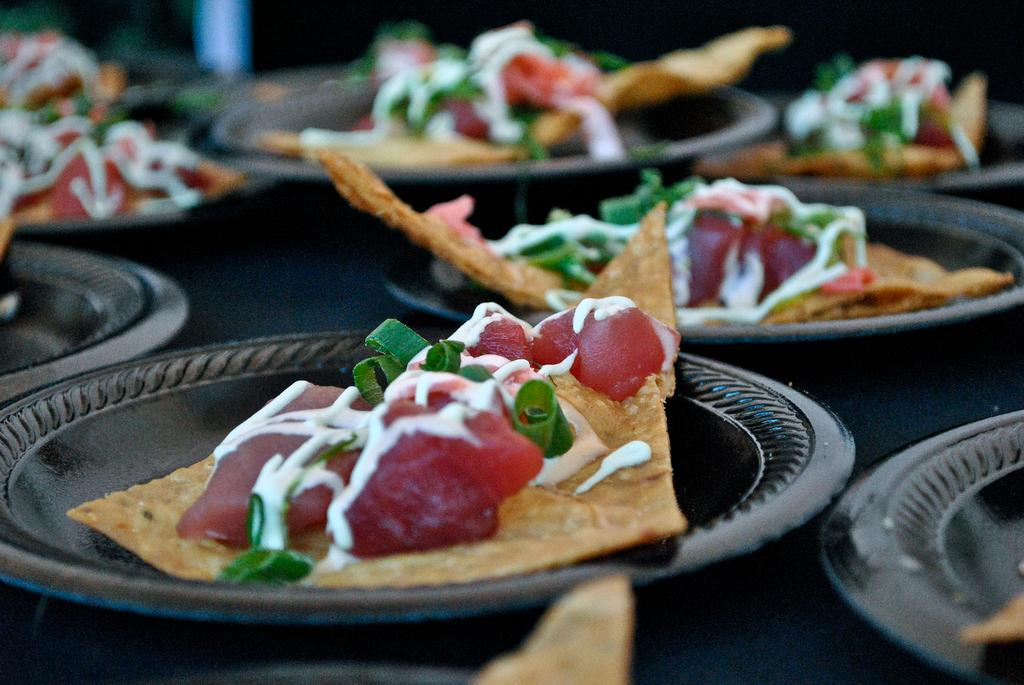What is on the plates in the image? There is food in the plates in the image. What type of food can be seen on the plates? The food appears to be nachos. What is the distribution of the sound waves in the image? There is no mention of sound waves or hearing in the image, so it is not possible to answer that question. 